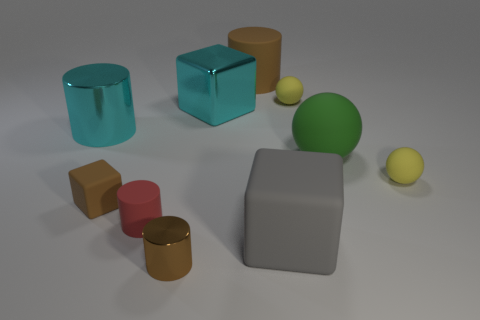Subtract all brown cubes. Subtract all red cylinders. How many cubes are left? 2 Subtract all cylinders. How many objects are left? 6 Subtract all big brown rubber things. Subtract all tiny yellow balls. How many objects are left? 7 Add 8 cyan blocks. How many cyan blocks are left? 9 Add 1 big rubber cubes. How many big rubber cubes exist? 2 Subtract 0 purple cylinders. How many objects are left? 10 